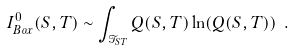<formula> <loc_0><loc_0><loc_500><loc_500>I _ { B o x } ^ { 0 } ( S , T ) \sim \int _ { \mathcal { T } _ { S T } } Q ( S , T ) \ln ( Q ( S , T ) ) \ .</formula> 